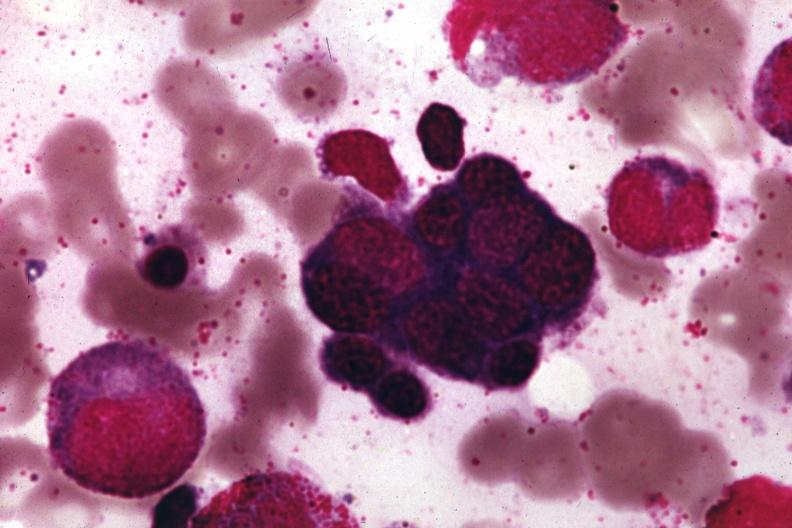s normal present?
Answer the question using a single word or phrase. No 